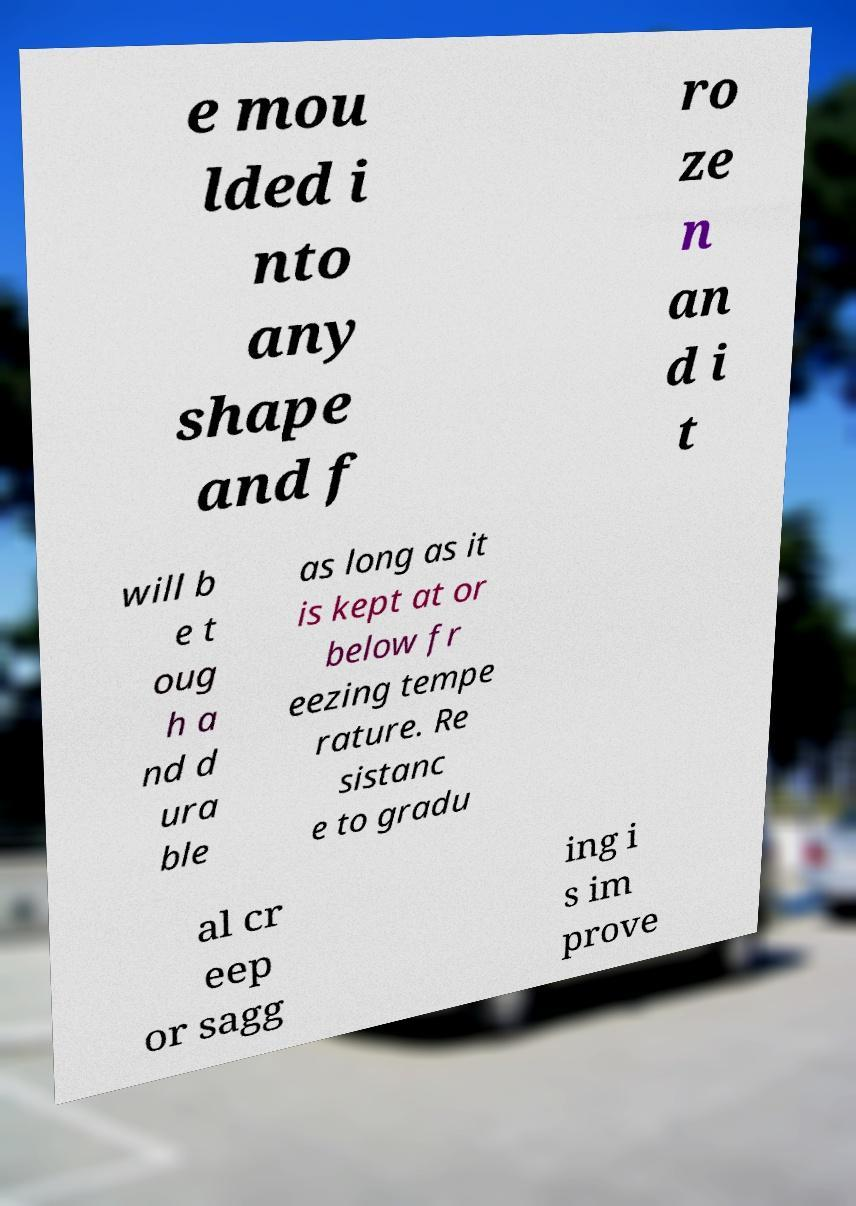Please identify and transcribe the text found in this image. e mou lded i nto any shape and f ro ze n an d i t will b e t oug h a nd d ura ble as long as it is kept at or below fr eezing tempe rature. Re sistanc e to gradu al cr eep or sagg ing i s im prove 